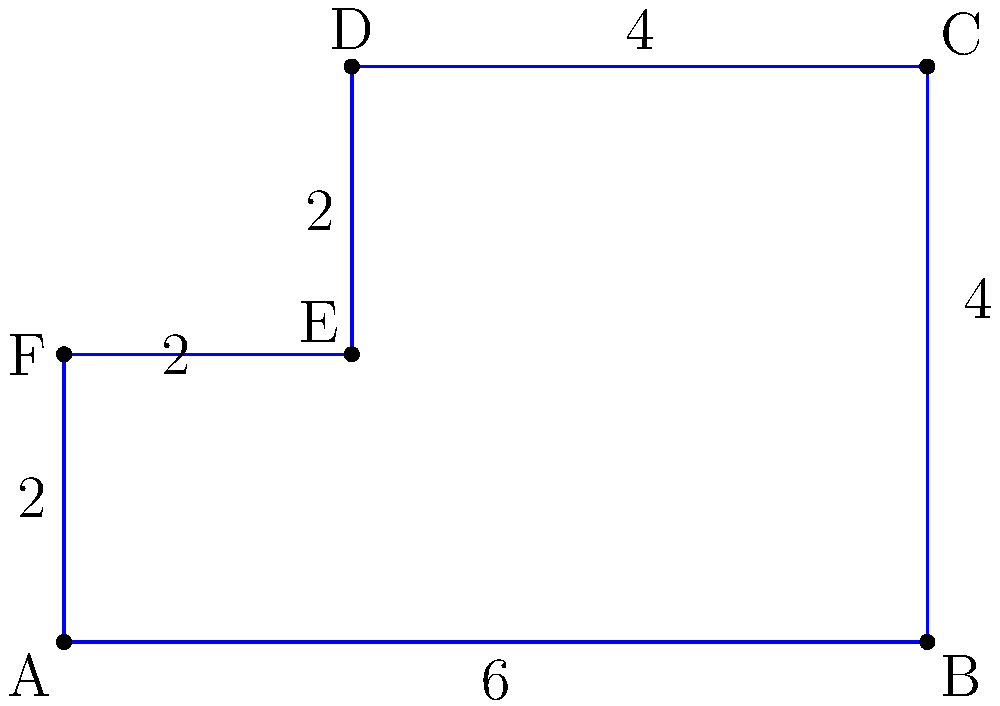As a property developer, you've acquired an irregularly shaped lot as shown in the diagram. The lot undergoes the following transformations:
1. A dilation with scale factor 1.5 centered at point A
2. A rotation of 90° clockwise about point A
3. A translation of 3 units right and 2 units up

Calculate the area of the transformed lot in square units. Let's approach this step-by-step:

1) First, we need to calculate the initial area of the lot:
   The lot can be divided into a 6x4 rectangle and a 2x2 square.
   Area = $(6 \times 4) + (2 \times 2) = 24 + 4 = 28$ square units

2) After the dilation with scale factor 1.5:
   New area = $28 \times 1.5^2 = 28 \times 2.25 = 63$ square units
   (The area scales by the square of the scale factor)

3) The rotation doesn't change the area of the lot.

4) The translation also doesn't change the area of the lot.

Therefore, the final area of the transformed lot remains 63 square units.
Answer: 63 square units 